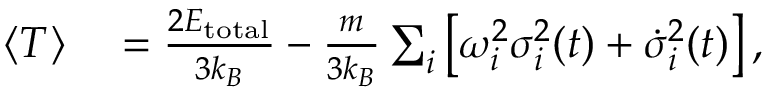Convert formula to latex. <formula><loc_0><loc_0><loc_500><loc_500>\begin{array} { r l } { \langle T \rangle } & = \frac { 2 E _ { t o t a l } } { 3 k _ { B } } - \frac { m } { 3 k _ { B } } \sum _ { i } \left [ \omega _ { i } ^ { 2 } \sigma _ { i } ^ { 2 } ( t ) + \dot { \sigma } _ { i } ^ { 2 } ( t ) \right ] , } \end{array}</formula> 